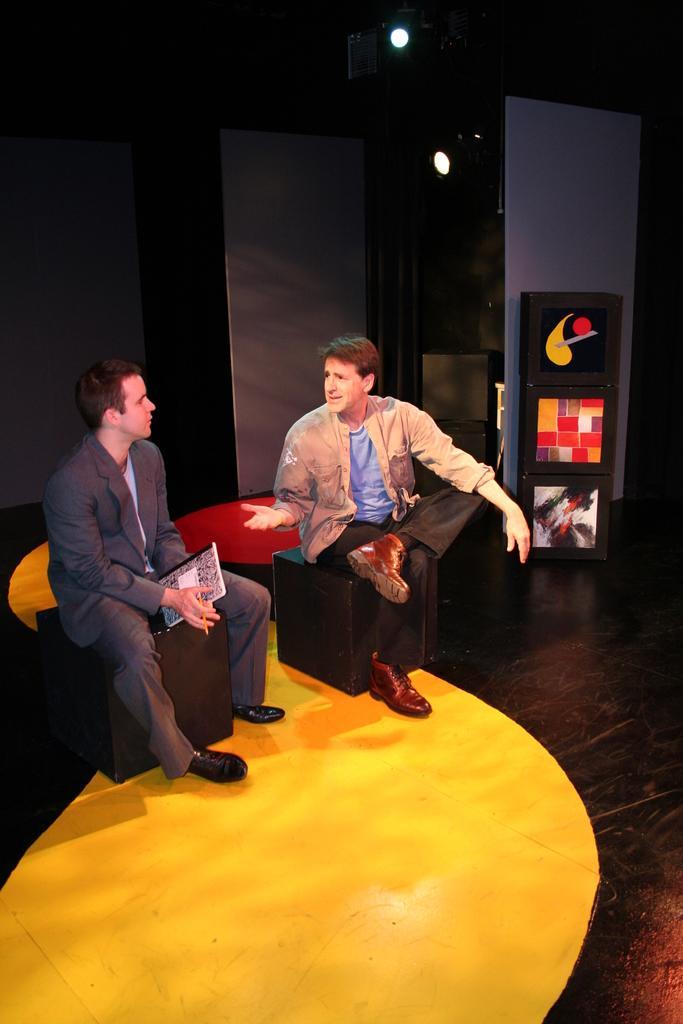How would you summarize this image in a sentence or two? In this picture I can observe two men sitting on the stools in the middle of the picture. In the background I can observe wall. 